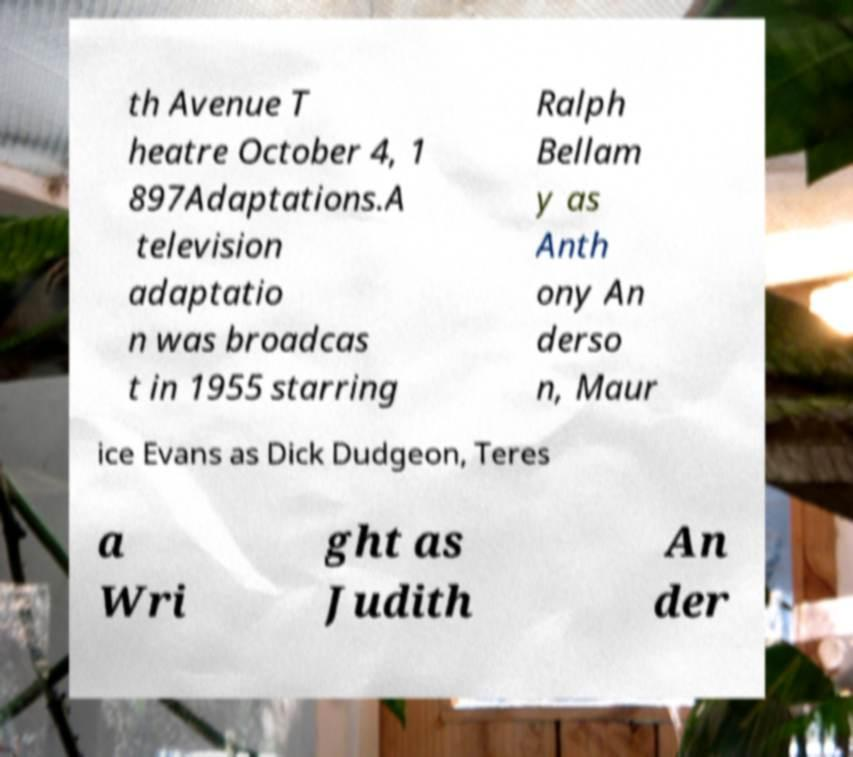Please identify and transcribe the text found in this image. th Avenue T heatre October 4, 1 897Adaptations.A television adaptatio n was broadcas t in 1955 starring Ralph Bellam y as Anth ony An derso n, Maur ice Evans as Dick Dudgeon, Teres a Wri ght as Judith An der 